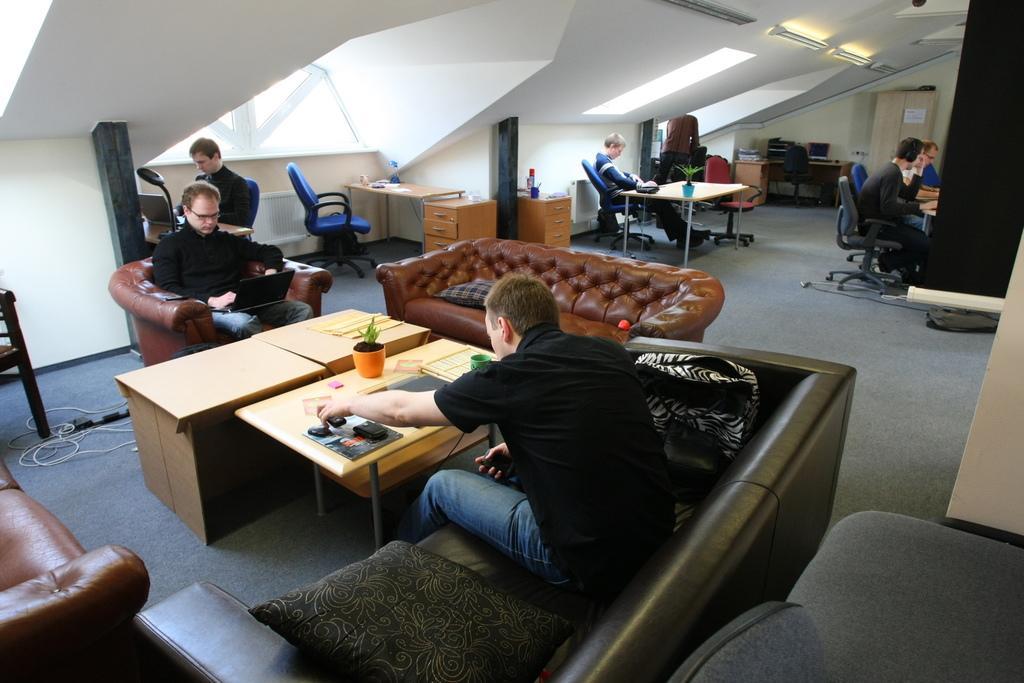In one or two sentences, can you explain what this image depicts? This image is taken in a room. In the bottom there is a person sitting on a sofa, he is wearing a black t shirt and blue jeans and he is holding something. On the table there is a plant, a cup and some books. Before the table there is an another table. On the top there are two persons, one person sitting in a sofa and staring at a laptop, another person sitting behind him and he wearing a black t shirt and he is working on system. Towards the right there are some people sitting on chairs, leaning towards the table, behind them there is another person sitting on chairs and staring at something. The room is filled with tables and chairs and sofas. 